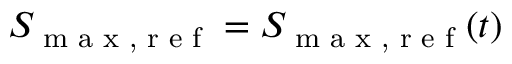<formula> <loc_0><loc_0><loc_500><loc_500>S _ { \max , r e f } = S _ { \max , r e f } ( t )</formula> 